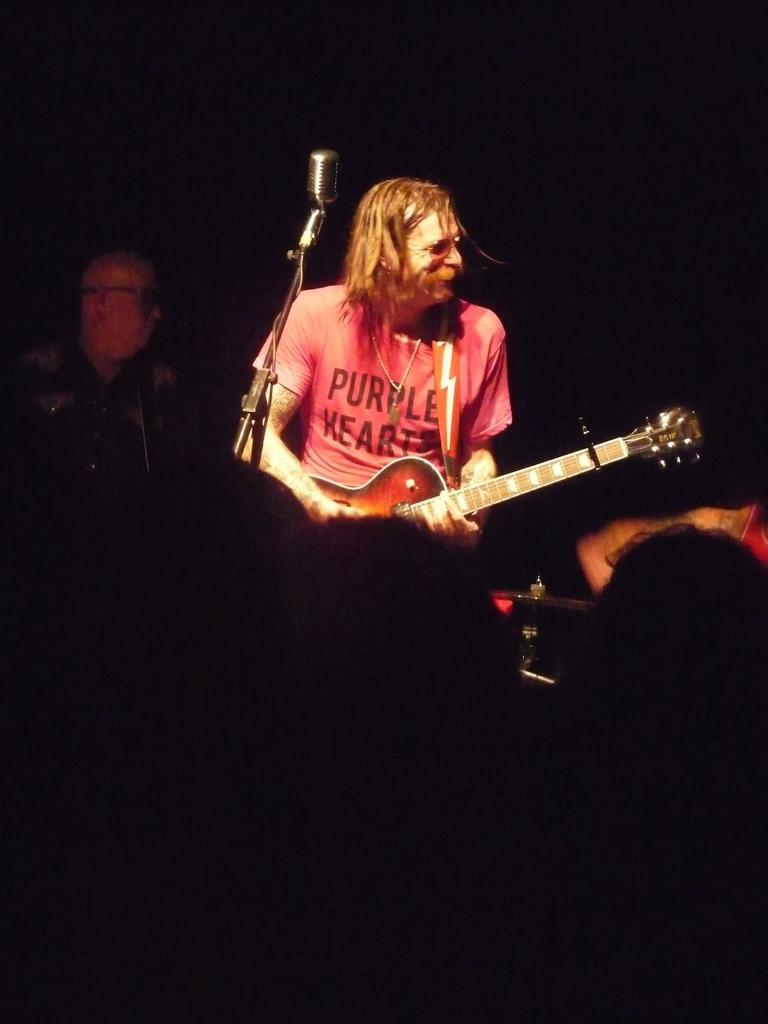Who is the main subject in the image? There is a man in the image. What is the man wearing? The man is wearing a pink shirt. What is the man doing in the image? The man is playing a guitar. What object is the man in front of? The man is in front of a microphone. Are there any other people in the image? Yes, there is another man standing on the left side of the image. What type of cave can be seen in the background of the image? There is no cave present in the image; it features a man playing a guitar in front of a microphone. What kind of machine is the man using to play the guitar? The man is not using a machine to play the guitar; he is playing it manually. 